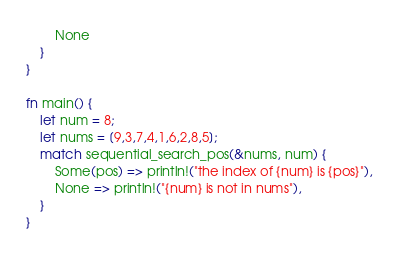<code> <loc_0><loc_0><loc_500><loc_500><_Rust_>        None
    }
}

fn main() {
    let num = 8;
    let nums = [9,3,7,4,1,6,2,8,5];
    match sequential_search_pos(&nums, num) {
        Some(pos) => println!("the index of {num} is {pos}"),
        None => println!("{num} is not in nums"),
    }
}
</code> 